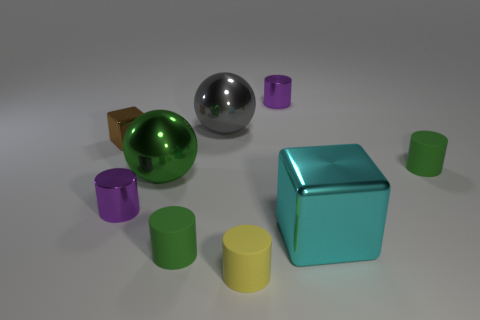Subtract all small purple cylinders. How many cylinders are left? 3 Subtract all cylinders. How many objects are left? 4 Subtract 5 cylinders. How many cylinders are left? 0 Subtract all blue cylinders. Subtract all yellow spheres. How many cylinders are left? 5 Subtract all blue spheres. How many yellow cylinders are left? 1 Subtract all tiny green cylinders. Subtract all tiny yellow cylinders. How many objects are left? 6 Add 7 tiny rubber objects. How many tiny rubber objects are left? 10 Add 6 cyan blocks. How many cyan blocks exist? 7 Add 1 red metallic cubes. How many objects exist? 10 Subtract all green cylinders. How many cylinders are left? 3 